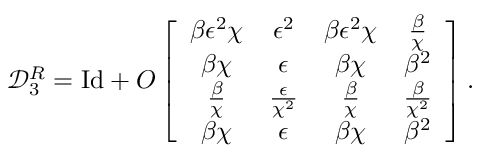<formula> <loc_0><loc_0><loc_500><loc_500>\mathcal { D } _ { 3 } ^ { R } = I d + O \left [ \begin{array} { c c c c } { \beta \epsilon ^ { 2 } \chi } & { \epsilon ^ { 2 } } & { \beta \epsilon ^ { 2 } \chi } & { \frac { \beta } { \chi } } \\ { \beta \chi } & { \epsilon } & { \beta \chi } & { \beta ^ { 2 } } \\ { \frac { \beta } { \chi } } & { \frac { \epsilon } { \chi ^ { 2 } } } & { \frac { \beta } { \chi } } & { \frac { \beta } { \chi ^ { 2 } } } \\ { \beta \chi } & { \epsilon } & { \beta \chi } & { \beta ^ { 2 } } \end{array} \right ] .</formula> 